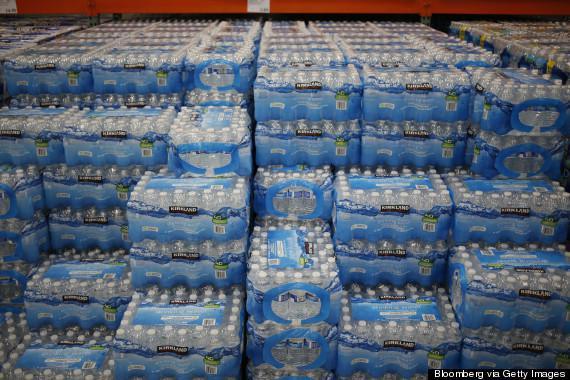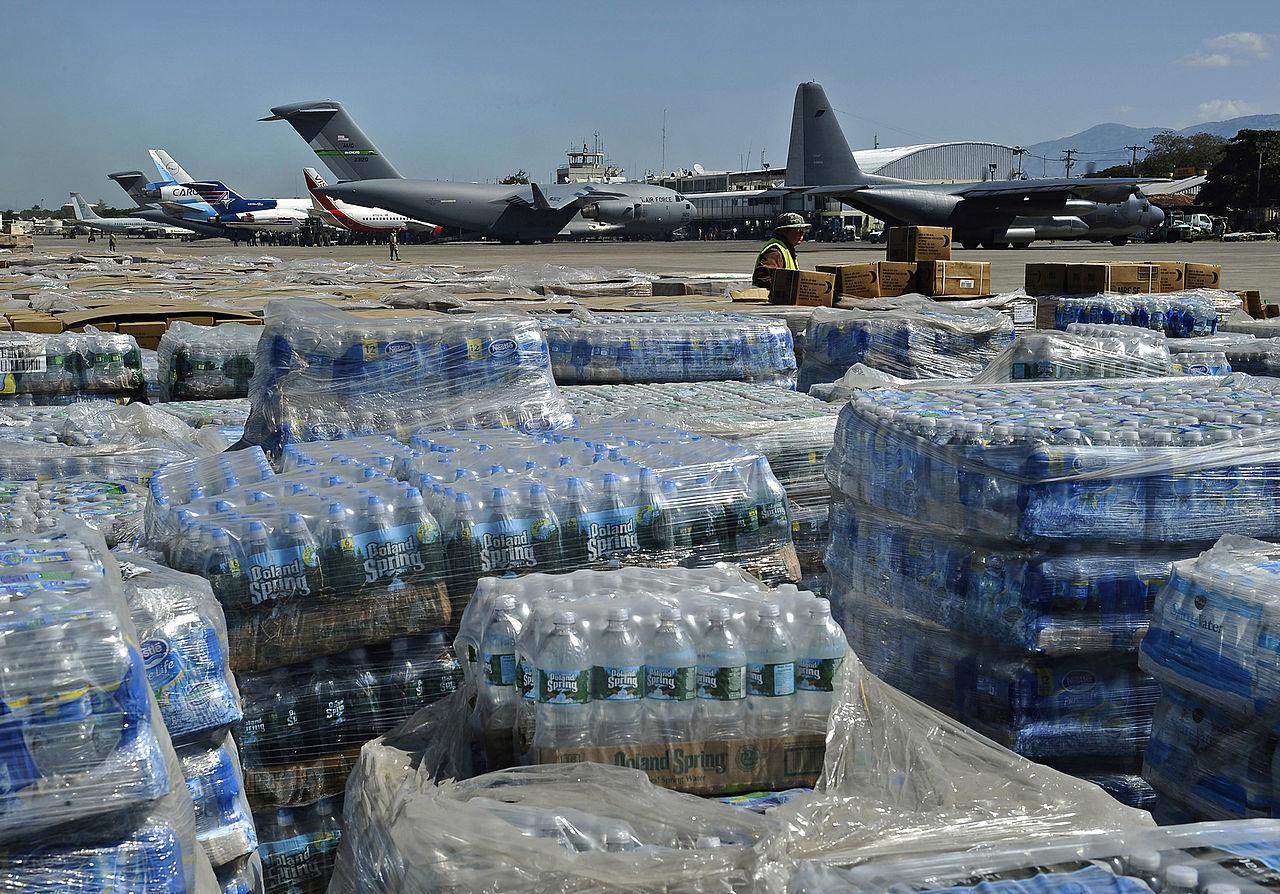The first image is the image on the left, the second image is the image on the right. Evaluate the accuracy of this statement regarding the images: "In the image on the right the water bottles are stacked on shelves.". Is it true? Answer yes or no. No. 